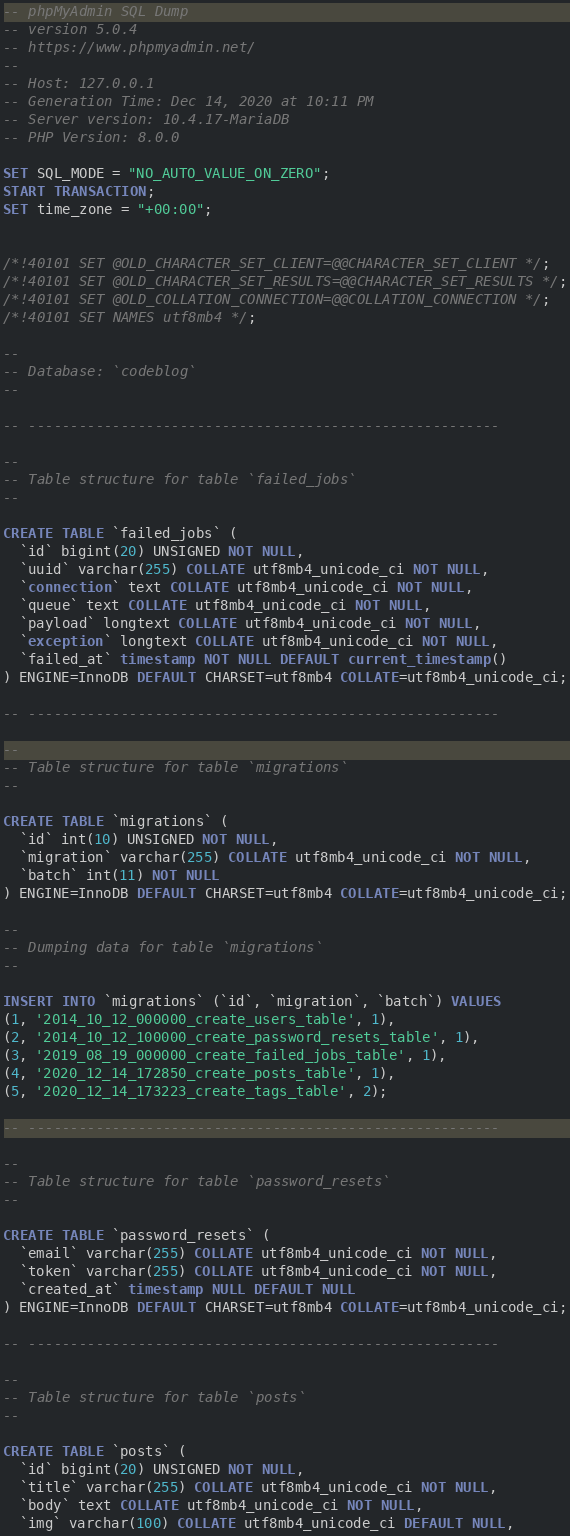Convert code to text. <code><loc_0><loc_0><loc_500><loc_500><_SQL_>-- phpMyAdmin SQL Dump
-- version 5.0.4
-- https://www.phpmyadmin.net/
--
-- Host: 127.0.0.1
-- Generation Time: Dec 14, 2020 at 10:11 PM
-- Server version: 10.4.17-MariaDB
-- PHP Version: 8.0.0

SET SQL_MODE = "NO_AUTO_VALUE_ON_ZERO";
START TRANSACTION;
SET time_zone = "+00:00";


/*!40101 SET @OLD_CHARACTER_SET_CLIENT=@@CHARACTER_SET_CLIENT */;
/*!40101 SET @OLD_CHARACTER_SET_RESULTS=@@CHARACTER_SET_RESULTS */;
/*!40101 SET @OLD_COLLATION_CONNECTION=@@COLLATION_CONNECTION */;
/*!40101 SET NAMES utf8mb4 */;

--
-- Database: `codeblog`
--

-- --------------------------------------------------------

--
-- Table structure for table `failed_jobs`
--

CREATE TABLE `failed_jobs` (
  `id` bigint(20) UNSIGNED NOT NULL,
  `uuid` varchar(255) COLLATE utf8mb4_unicode_ci NOT NULL,
  `connection` text COLLATE utf8mb4_unicode_ci NOT NULL,
  `queue` text COLLATE utf8mb4_unicode_ci NOT NULL,
  `payload` longtext COLLATE utf8mb4_unicode_ci NOT NULL,
  `exception` longtext COLLATE utf8mb4_unicode_ci NOT NULL,
  `failed_at` timestamp NOT NULL DEFAULT current_timestamp()
) ENGINE=InnoDB DEFAULT CHARSET=utf8mb4 COLLATE=utf8mb4_unicode_ci;

-- --------------------------------------------------------

--
-- Table structure for table `migrations`
--

CREATE TABLE `migrations` (
  `id` int(10) UNSIGNED NOT NULL,
  `migration` varchar(255) COLLATE utf8mb4_unicode_ci NOT NULL,
  `batch` int(11) NOT NULL
) ENGINE=InnoDB DEFAULT CHARSET=utf8mb4 COLLATE=utf8mb4_unicode_ci;

--
-- Dumping data for table `migrations`
--

INSERT INTO `migrations` (`id`, `migration`, `batch`) VALUES
(1, '2014_10_12_000000_create_users_table', 1),
(2, '2014_10_12_100000_create_password_resets_table', 1),
(3, '2019_08_19_000000_create_failed_jobs_table', 1),
(4, '2020_12_14_172850_create_posts_table', 1),
(5, '2020_12_14_173223_create_tags_table', 2);

-- --------------------------------------------------------

--
-- Table structure for table `password_resets`
--

CREATE TABLE `password_resets` (
  `email` varchar(255) COLLATE utf8mb4_unicode_ci NOT NULL,
  `token` varchar(255) COLLATE utf8mb4_unicode_ci NOT NULL,
  `created_at` timestamp NULL DEFAULT NULL
) ENGINE=InnoDB DEFAULT CHARSET=utf8mb4 COLLATE=utf8mb4_unicode_ci;

-- --------------------------------------------------------

--
-- Table structure for table `posts`
--

CREATE TABLE `posts` (
  `id` bigint(20) UNSIGNED NOT NULL,
  `title` varchar(255) COLLATE utf8mb4_unicode_ci NOT NULL,
  `body` text COLLATE utf8mb4_unicode_ci NOT NULL,
  `img` varchar(100) COLLATE utf8mb4_unicode_ci DEFAULT NULL,</code> 